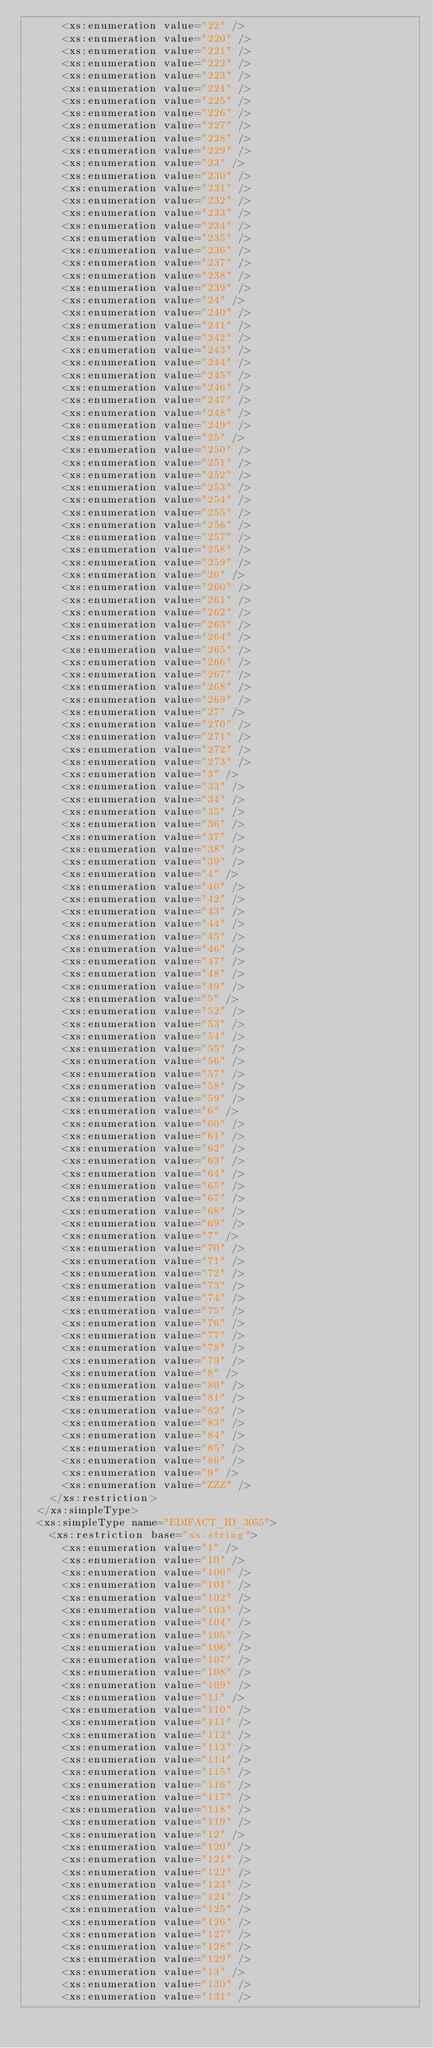Convert code to text. <code><loc_0><loc_0><loc_500><loc_500><_XML_>      <xs:enumeration value="22" />
      <xs:enumeration value="220" />
      <xs:enumeration value="221" />
      <xs:enumeration value="222" />
      <xs:enumeration value="223" />
      <xs:enumeration value="224" />
      <xs:enumeration value="225" />
      <xs:enumeration value="226" />
      <xs:enumeration value="227" />
      <xs:enumeration value="228" />
      <xs:enumeration value="229" />
      <xs:enumeration value="23" />
      <xs:enumeration value="230" />
      <xs:enumeration value="231" />
      <xs:enumeration value="232" />
      <xs:enumeration value="233" />
      <xs:enumeration value="234" />
      <xs:enumeration value="235" />
      <xs:enumeration value="236" />
      <xs:enumeration value="237" />
      <xs:enumeration value="238" />
      <xs:enumeration value="239" />
      <xs:enumeration value="24" />
      <xs:enumeration value="240" />
      <xs:enumeration value="241" />
      <xs:enumeration value="242" />
      <xs:enumeration value="243" />
      <xs:enumeration value="244" />
      <xs:enumeration value="245" />
      <xs:enumeration value="246" />
      <xs:enumeration value="247" />
      <xs:enumeration value="248" />
      <xs:enumeration value="249" />
      <xs:enumeration value="25" />
      <xs:enumeration value="250" />
      <xs:enumeration value="251" />
      <xs:enumeration value="252" />
      <xs:enumeration value="253" />
      <xs:enumeration value="254" />
      <xs:enumeration value="255" />
      <xs:enumeration value="256" />
      <xs:enumeration value="257" />
      <xs:enumeration value="258" />
      <xs:enumeration value="259" />
      <xs:enumeration value="26" />
      <xs:enumeration value="260" />
      <xs:enumeration value="261" />
      <xs:enumeration value="262" />
      <xs:enumeration value="263" />
      <xs:enumeration value="264" />
      <xs:enumeration value="265" />
      <xs:enumeration value="266" />
      <xs:enumeration value="267" />
      <xs:enumeration value="268" />
      <xs:enumeration value="269" />
      <xs:enumeration value="27" />
      <xs:enumeration value="270" />
      <xs:enumeration value="271" />
      <xs:enumeration value="272" />
      <xs:enumeration value="273" />
      <xs:enumeration value="3" />
      <xs:enumeration value="33" />
      <xs:enumeration value="34" />
      <xs:enumeration value="35" />
      <xs:enumeration value="36" />
      <xs:enumeration value="37" />
      <xs:enumeration value="38" />
      <xs:enumeration value="39" />
      <xs:enumeration value="4" />
      <xs:enumeration value="40" />
      <xs:enumeration value="42" />
      <xs:enumeration value="43" />
      <xs:enumeration value="44" />
      <xs:enumeration value="45" />
      <xs:enumeration value="46" />
      <xs:enumeration value="47" />
      <xs:enumeration value="48" />
      <xs:enumeration value="49" />
      <xs:enumeration value="5" />
      <xs:enumeration value="52" />
      <xs:enumeration value="53" />
      <xs:enumeration value="54" />
      <xs:enumeration value="55" />
      <xs:enumeration value="56" />
      <xs:enumeration value="57" />
      <xs:enumeration value="58" />
      <xs:enumeration value="59" />
      <xs:enumeration value="6" />
      <xs:enumeration value="60" />
      <xs:enumeration value="61" />
      <xs:enumeration value="62" />
      <xs:enumeration value="63" />
      <xs:enumeration value="64" />
      <xs:enumeration value="65" />
      <xs:enumeration value="67" />
      <xs:enumeration value="68" />
      <xs:enumeration value="69" />
      <xs:enumeration value="7" />
      <xs:enumeration value="70" />
      <xs:enumeration value="71" />
      <xs:enumeration value="72" />
      <xs:enumeration value="73" />
      <xs:enumeration value="74" />
      <xs:enumeration value="75" />
      <xs:enumeration value="76" />
      <xs:enumeration value="77" />
      <xs:enumeration value="78" />
      <xs:enumeration value="79" />
      <xs:enumeration value="8" />
      <xs:enumeration value="80" />
      <xs:enumeration value="81" />
      <xs:enumeration value="82" />
      <xs:enumeration value="83" />
      <xs:enumeration value="84" />
      <xs:enumeration value="85" />
      <xs:enumeration value="86" />
      <xs:enumeration value="9" />
      <xs:enumeration value="ZZZ" />
    </xs:restriction>
  </xs:simpleType>
  <xs:simpleType name="EDIFACT_ID_3055">
    <xs:restriction base="xs:string">
      <xs:enumeration value="1" />
      <xs:enumeration value="10" />
      <xs:enumeration value="100" />
      <xs:enumeration value="101" />
      <xs:enumeration value="102" />
      <xs:enumeration value="103" />
      <xs:enumeration value="104" />
      <xs:enumeration value="105" />
      <xs:enumeration value="106" />
      <xs:enumeration value="107" />
      <xs:enumeration value="108" />
      <xs:enumeration value="109" />
      <xs:enumeration value="11" />
      <xs:enumeration value="110" />
      <xs:enumeration value="111" />
      <xs:enumeration value="112" />
      <xs:enumeration value="113" />
      <xs:enumeration value="114" />
      <xs:enumeration value="115" />
      <xs:enumeration value="116" />
      <xs:enumeration value="117" />
      <xs:enumeration value="118" />
      <xs:enumeration value="119" />
      <xs:enumeration value="12" />
      <xs:enumeration value="120" />
      <xs:enumeration value="121" />
      <xs:enumeration value="122" />
      <xs:enumeration value="123" />
      <xs:enumeration value="124" />
      <xs:enumeration value="125" />
      <xs:enumeration value="126" />
      <xs:enumeration value="127" />
      <xs:enumeration value="128" />
      <xs:enumeration value="129" />
      <xs:enumeration value="13" />
      <xs:enumeration value="130" />
      <xs:enumeration value="131" /></code> 